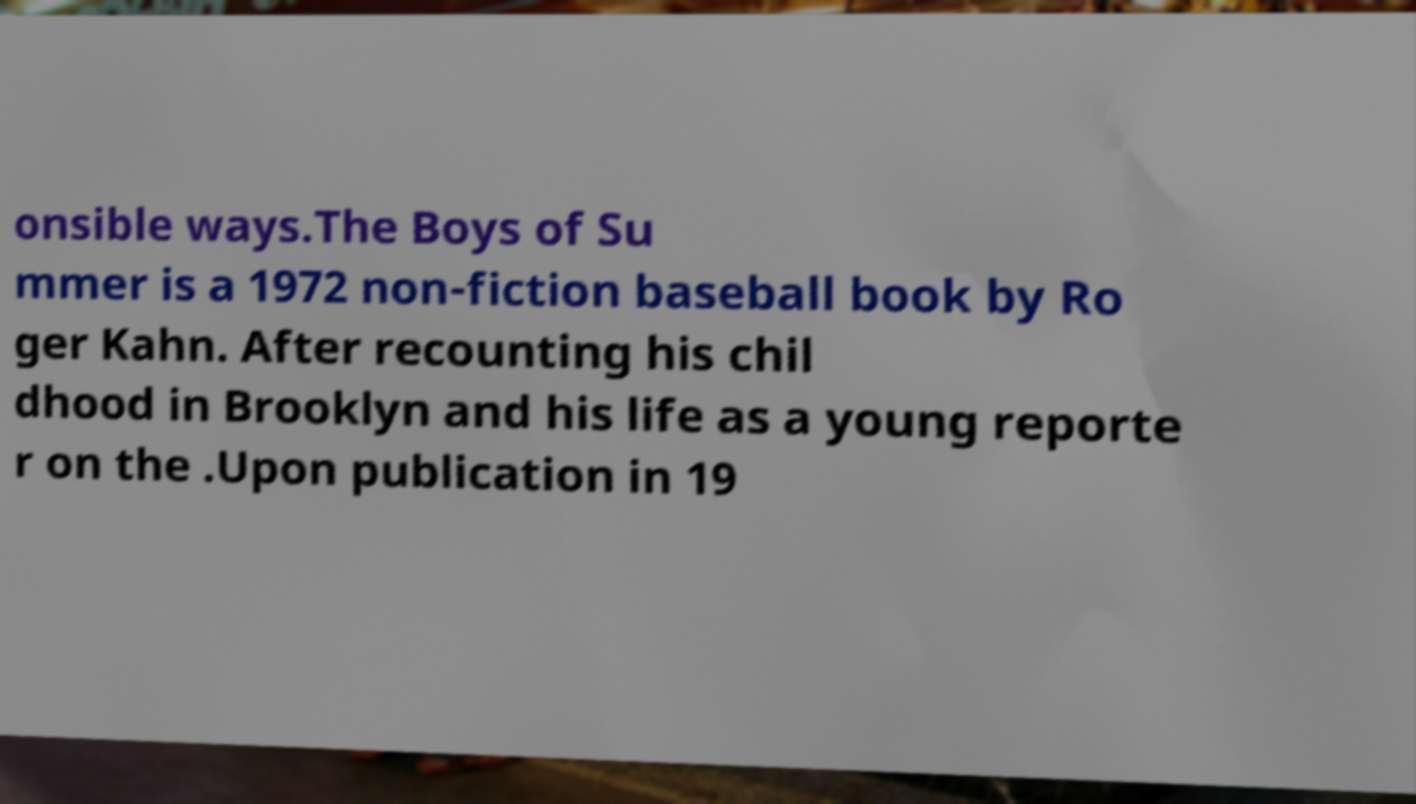Could you assist in decoding the text presented in this image and type it out clearly? onsible ways.The Boys of Su mmer is a 1972 non-fiction baseball book by Ro ger Kahn. After recounting his chil dhood in Brooklyn and his life as a young reporte r on the .Upon publication in 19 